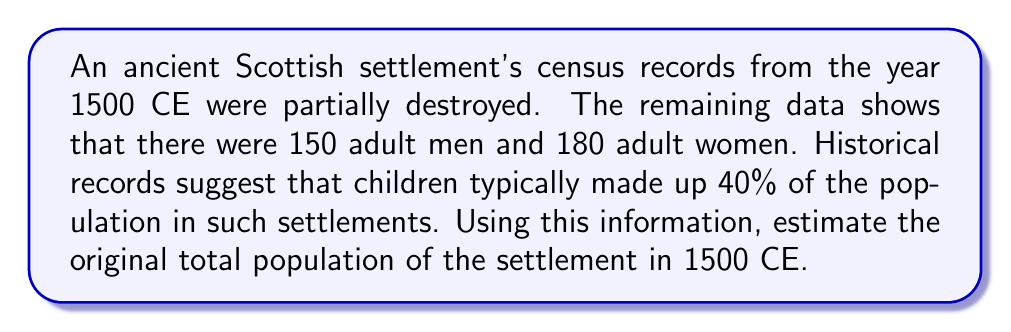Can you solve this math problem? Let's approach this step-by-step:

1) First, we need to calculate the total number of adults:
   $$ \text{Total Adults} = \text{Adult Men} + \text{Adult Women} $$
   $$ \text{Total Adults} = 150 + 180 = 330 $$

2) We know that children made up 40% of the population. This means adults made up the remaining 60%. We can set up an equation:
   $$ 330 = 0.60 \times \text{Total Population} $$

3) To solve for the total population, we divide both sides by 0.60:
   $$ \frac{330}{0.60} = \text{Total Population} $$

4) Calculating this:
   $$ \text{Total Population} = 550 $$

5) To verify, we can check:
   60% of 550 = $550 \times 0.60 = 330$ (adults)
   40% of 550 = $550 \times 0.40 = 220$ (children)

Therefore, the estimated total population of the settlement in 1500 CE was 550 people.
Answer: 550 people 